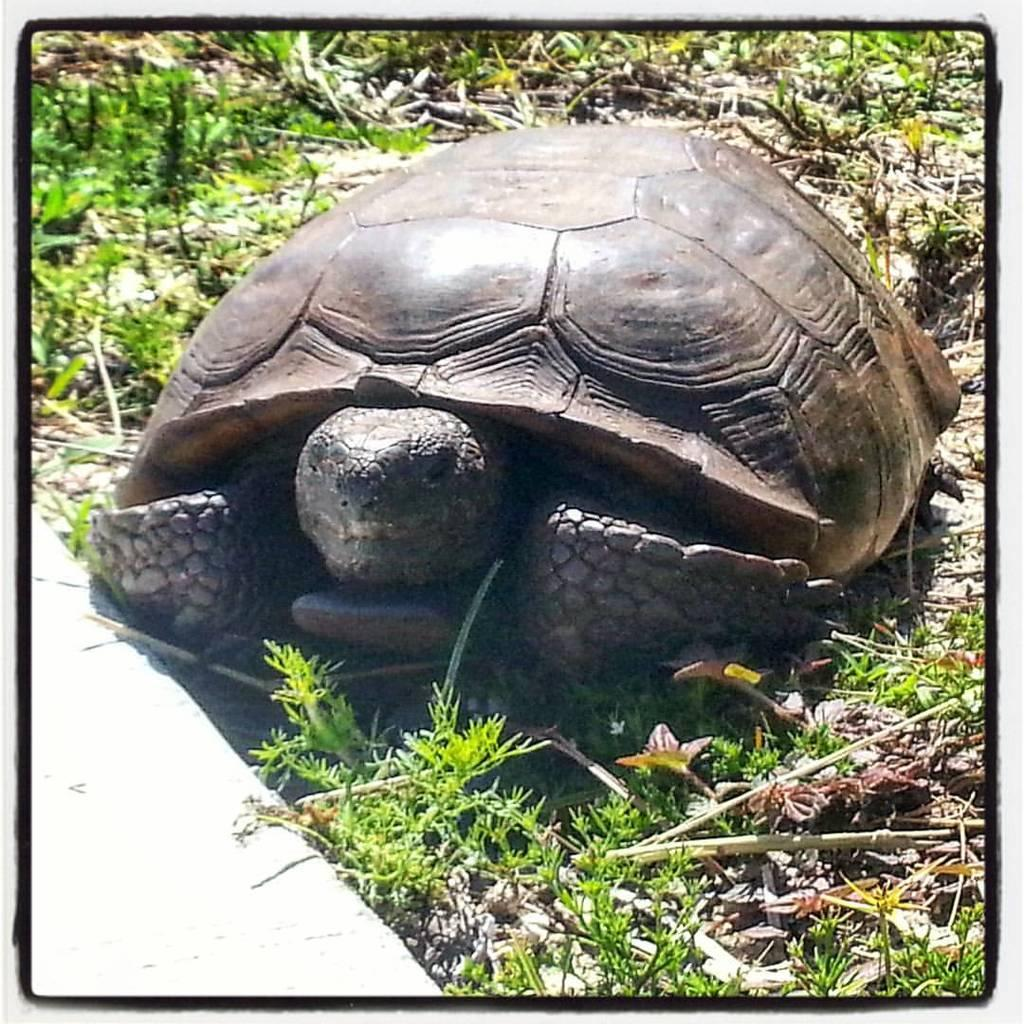What animal is in the foreground of the image? There is a tortoise in the foreground of the image. What else can be seen at the bottom of the image? There are plants at the bottom of the image. How fast is the snail running in the image? There is no snail present in the image, so it is not possible to determine its speed. 